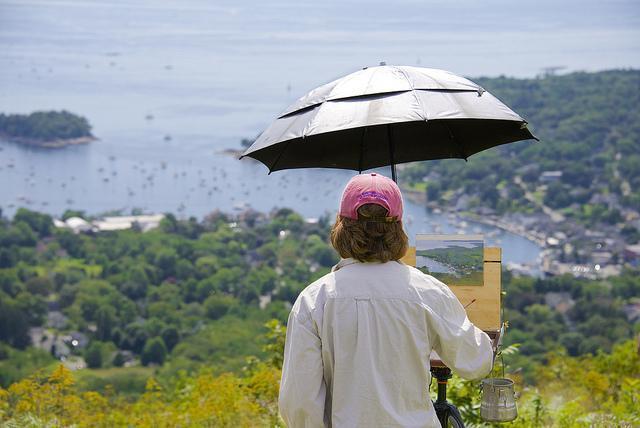What is in the metal tin?
Select the accurate response from the four choices given to answer the question.
Options: Water, erasers, paint, snacks. Water. 